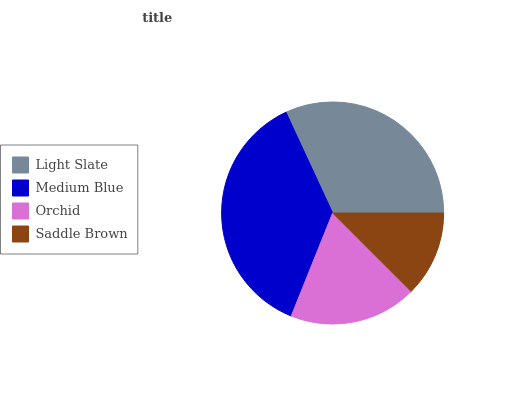Is Saddle Brown the minimum?
Answer yes or no. Yes. Is Medium Blue the maximum?
Answer yes or no. Yes. Is Orchid the minimum?
Answer yes or no. No. Is Orchid the maximum?
Answer yes or no. No. Is Medium Blue greater than Orchid?
Answer yes or no. Yes. Is Orchid less than Medium Blue?
Answer yes or no. Yes. Is Orchid greater than Medium Blue?
Answer yes or no. No. Is Medium Blue less than Orchid?
Answer yes or no. No. Is Light Slate the high median?
Answer yes or no. Yes. Is Orchid the low median?
Answer yes or no. Yes. Is Saddle Brown the high median?
Answer yes or no. No. Is Light Slate the low median?
Answer yes or no. No. 